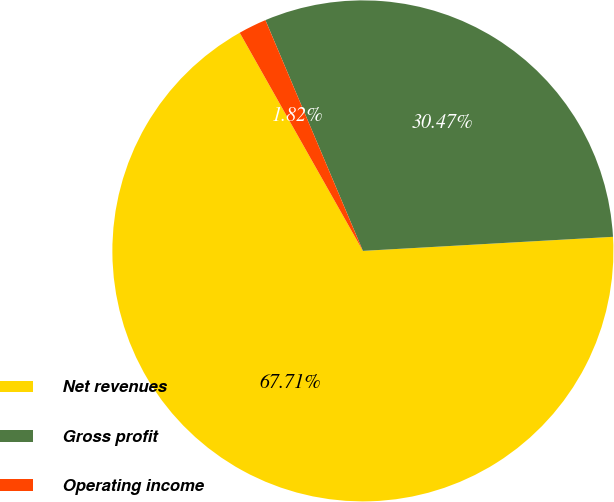Convert chart. <chart><loc_0><loc_0><loc_500><loc_500><pie_chart><fcel>Net revenues<fcel>Gross profit<fcel>Operating income<nl><fcel>67.72%<fcel>30.47%<fcel>1.82%<nl></chart> 